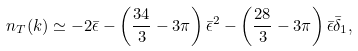<formula> <loc_0><loc_0><loc_500><loc_500>n _ { T } ( k ) \simeq - 2 \bar { \epsilon } - \left ( \frac { 3 4 } { 3 } - 3 \pi \right ) \bar { \epsilon } ^ { 2 } - \left ( \frac { 2 8 } { 3 } - 3 \pi \right ) \bar { \epsilon } \bar { \delta } _ { 1 } ,</formula> 